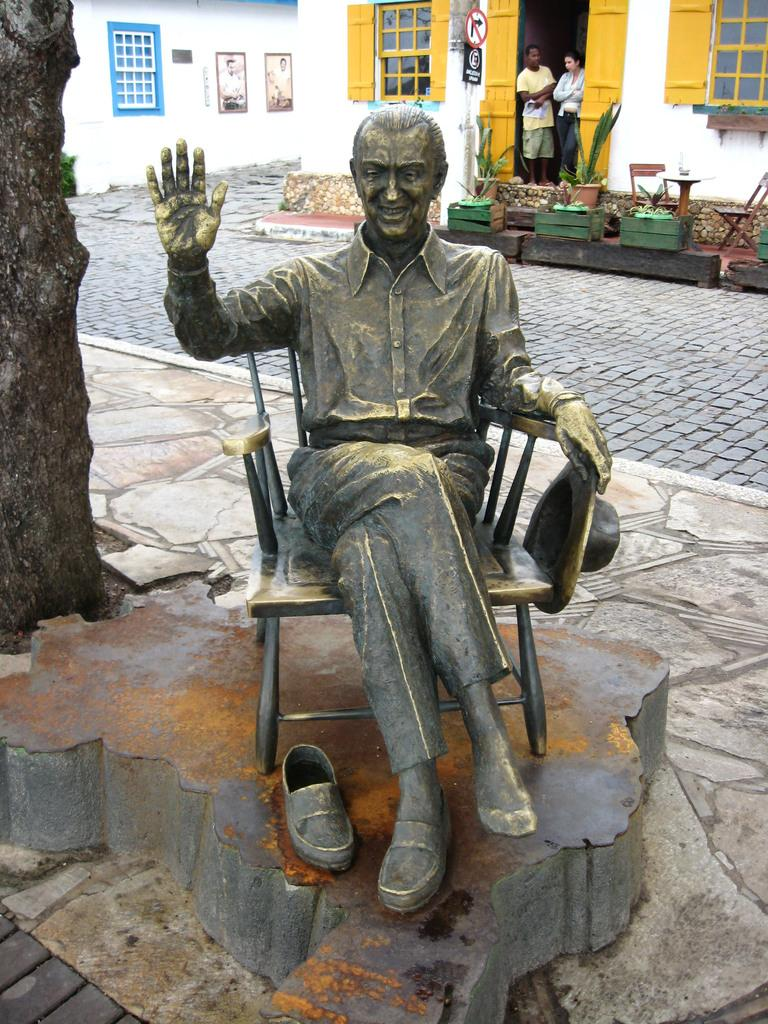What is the main subject in the center of the image? There is a statue in the center of the image. What can be seen on the left side of the image? There is a tree on the left side of the image. What is visible in the background of the image? Buildings, chairs, plants, windows, and persons are visible in the background of the image. Can you describe the architectural features in the background? There is a door in the background of the image. What type of salt is being used to season the statue in the image? There is no salt present in the image, and the statue is not being seasoned. 